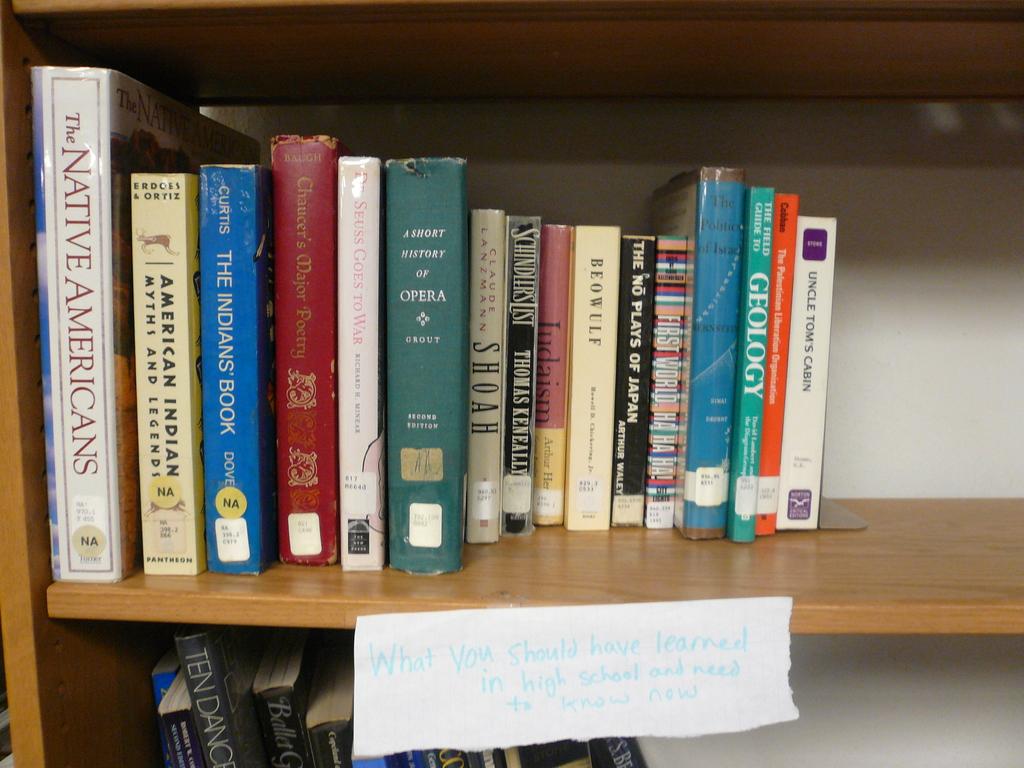What is the title of the book on the far right?
Keep it short and to the point. Uncle tom's cabin. What is the name of the white book all the way to the left?
Your answer should be compact. The native americans. 